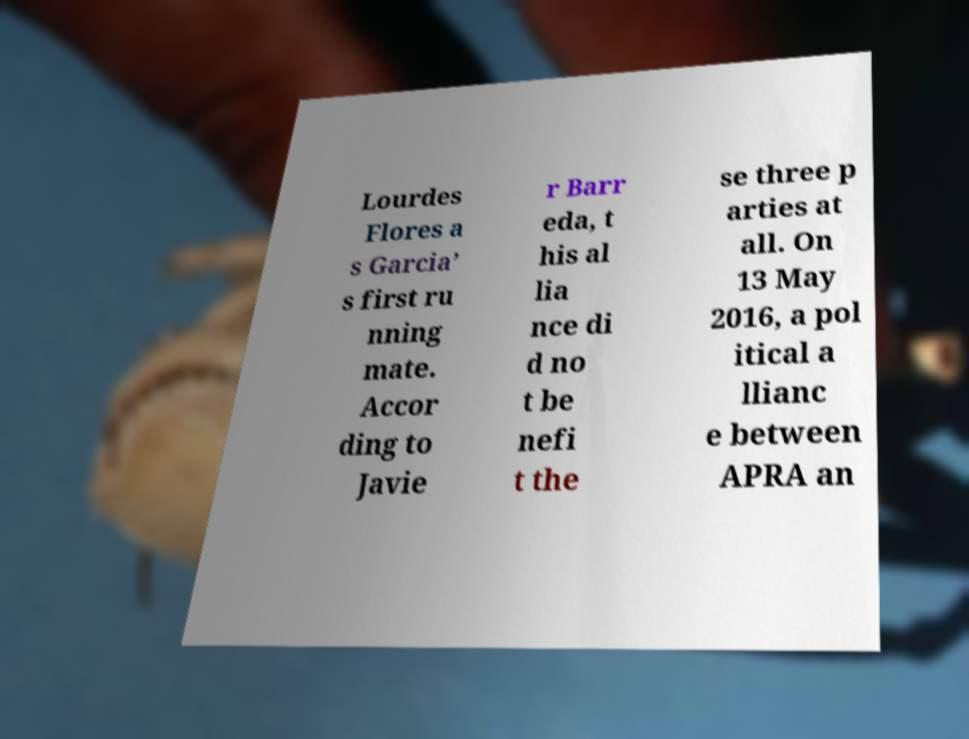Can you read and provide the text displayed in the image?This photo seems to have some interesting text. Can you extract and type it out for me? Lourdes Flores a s Garcia’ s first ru nning mate. Accor ding to Javie r Barr eda, t his al lia nce di d no t be nefi t the se three p arties at all. On 13 May 2016, a pol itical a llianc e between APRA an 